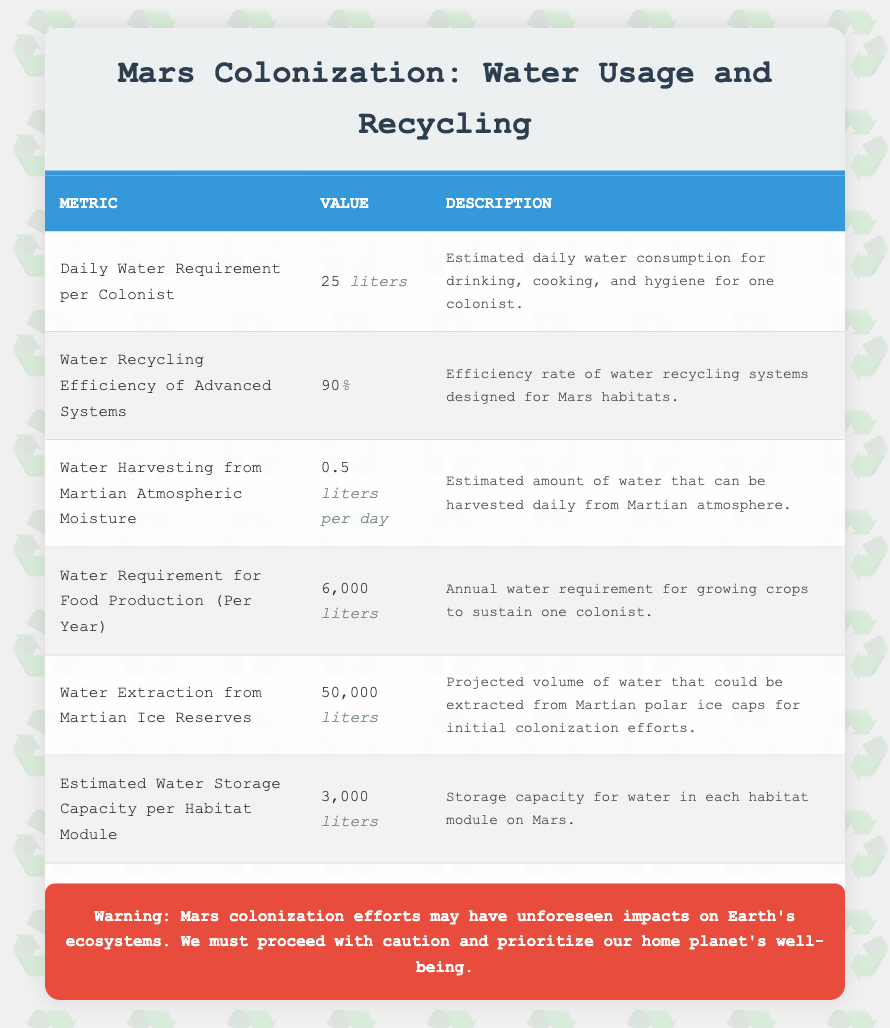What is the daily water requirement per colonist? The table lists the daily water requirement per colonist as 25 liters. This value is readily accessible in the first row of the table.
Answer: 25 liters What is the water recycling efficiency of advanced systems? According to the second row of the table, the water recycling efficiency of advanced systems is 90%. This is a straightforward retrieval from the provided data.
Answer: 90% How much water is required for food production per year for one colonist? The table states in the fourth entry that the annual water requirement for food production is 6,000 liters per colonist. This value is directly found in the table.
Answer: 6000 liters What is the total estimated water requirement for one colonist per year combining daily water and food production water? First, calculate the daily water usage per year: 25 liters/day * 365 days = 9,125 liters for daily activities. Then add the food production requirement: 9,125 + 6,000 = 15,125 liters. Thus, the total water requirement for one colonist per year is 15,125 liters.
Answer: 15125 liters Is the amount of water that can be harvested from Martian atmospheric moisture sufficient to meet the daily requirement of a colonist? The daily water requirement is 25 liters, while only 0.5 liters can be harvested from the Martian atmosphere daily. Since 0.5 liters is less than the 25 liters needed, it is insufficient.
Answer: No What is the estimated water storage capacity per habitat module on Mars? The table indicates that the storage capacity for water in each habitat module is 3,000 liters, found in the sixth entry of the table.
Answer: 3000 liters How much water can be extracted from Martian ice reserves compared to the daily requirement for one colonist? The table shows that 50,000 liters can be extracted from Martian ice reserves. The daily requirement is 25 liters. To relate them, we find that 50,000 liters / 25 liters = 2,000 days of water for one colonist, indicating a significant surplus.
Answer: Enough for 2000 days Is it possible for the current systems to recycle enough water to meet the total annual needs of one colonist? The total annual need is 15,125 liters. With a recycling efficiency of 90%, the amount of water that could be recycled is 90% of what is used, which implies approximately 13,612.5 liters could be recycled. Given that the total need is higher than the recycled amount, it means the systems would not suffice.
Answer: No What is the difference between the water extraction from Martian ice reserves and the estimated water storage capacity per habitat module? The water extraction capability is 50,000 liters, and the storage capacity is 3,000 liters. The difference is calculated as 50,000 - 3,000 = 47,000 liters.
Answer: 47000 liters 